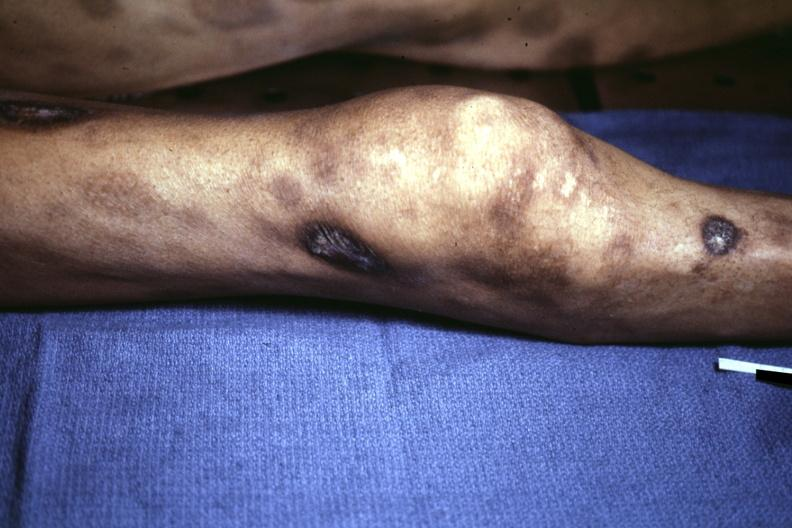what looks like pyoderma gangrenosum?
Answer the question using a single word or phrase. Necrotic and ulcerated centers 